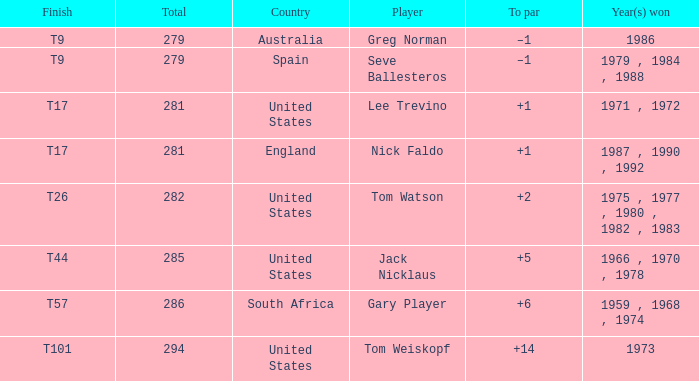Who has the highest total and a to par of +14? 294.0. 